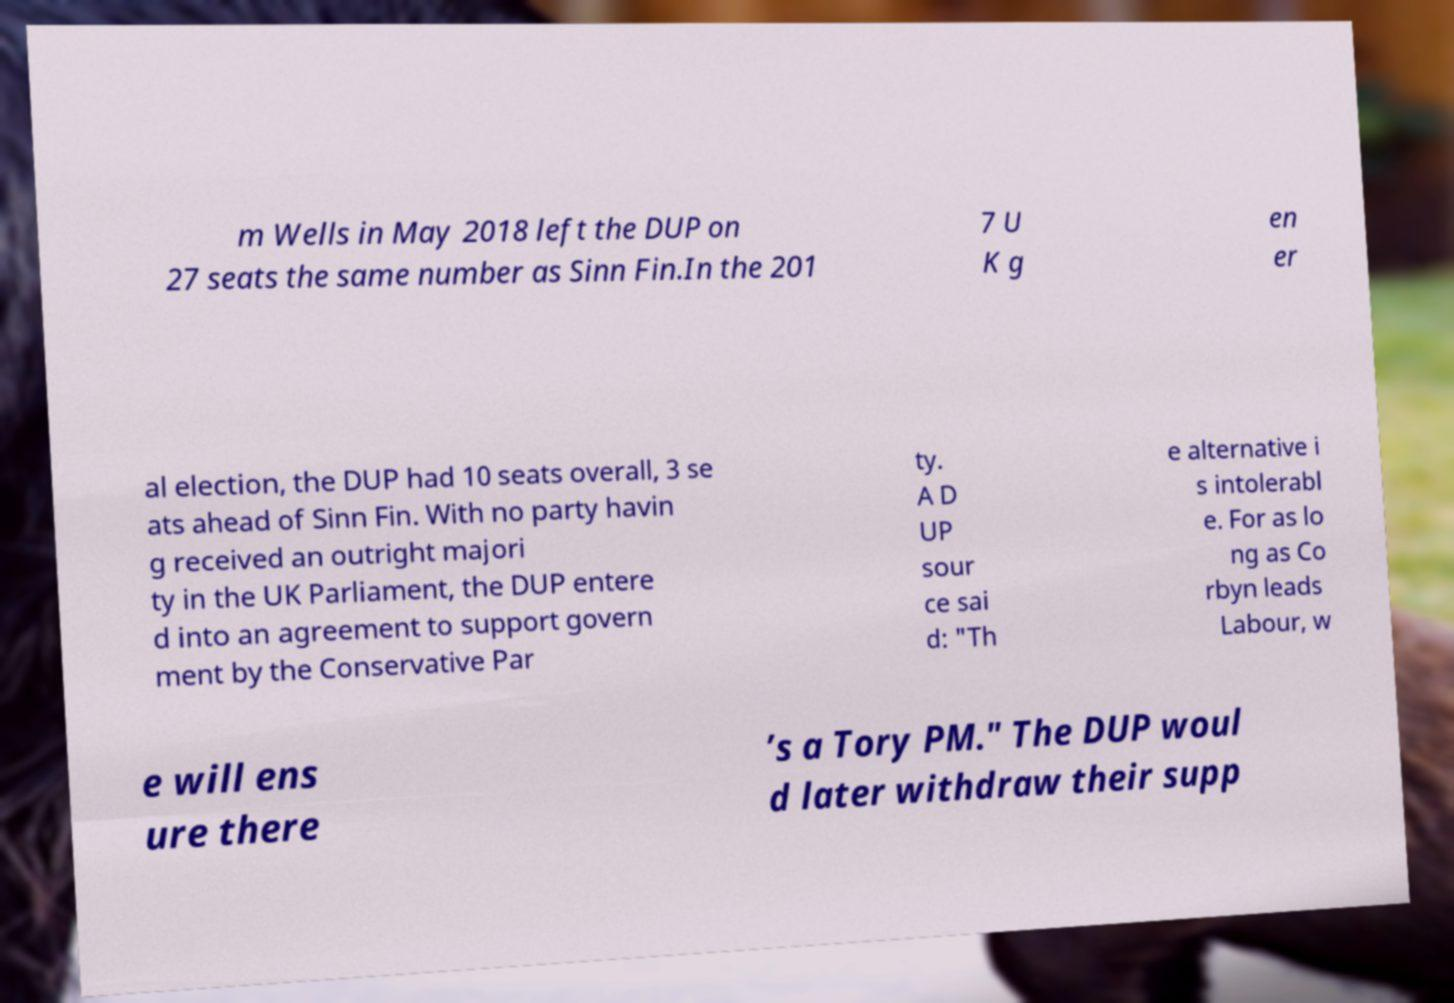Please identify and transcribe the text found in this image. m Wells in May 2018 left the DUP on 27 seats the same number as Sinn Fin.In the 201 7 U K g en er al election, the DUP had 10 seats overall, 3 se ats ahead of Sinn Fin. With no party havin g received an outright majori ty in the UK Parliament, the DUP entere d into an agreement to support govern ment by the Conservative Par ty. A D UP sour ce sai d: "Th e alternative i s intolerabl e. For as lo ng as Co rbyn leads Labour, w e will ens ure there ’s a Tory PM." The DUP woul d later withdraw their supp 